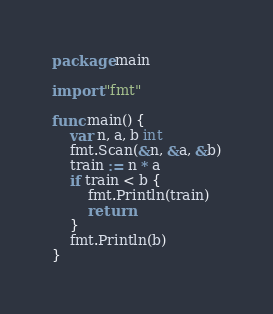Convert code to text. <code><loc_0><loc_0><loc_500><loc_500><_Go_>package main

import "fmt"

func main() {
	var n, a, b int
	fmt.Scan(&n, &a, &b)
	train := n * a
	if train < b {
		fmt.Println(train)
		return
	}
	fmt.Println(b)
}</code> 